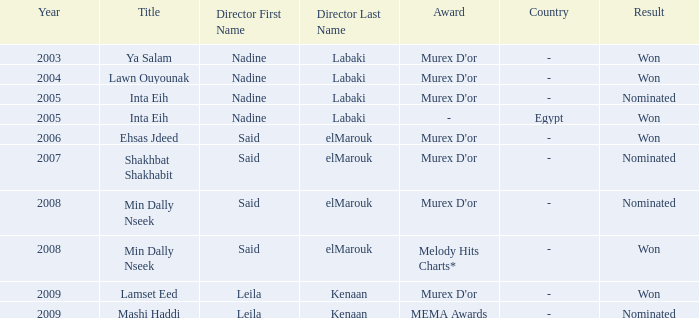What is the result for director Said Elmarouk before 2008? Won, Nominated. 